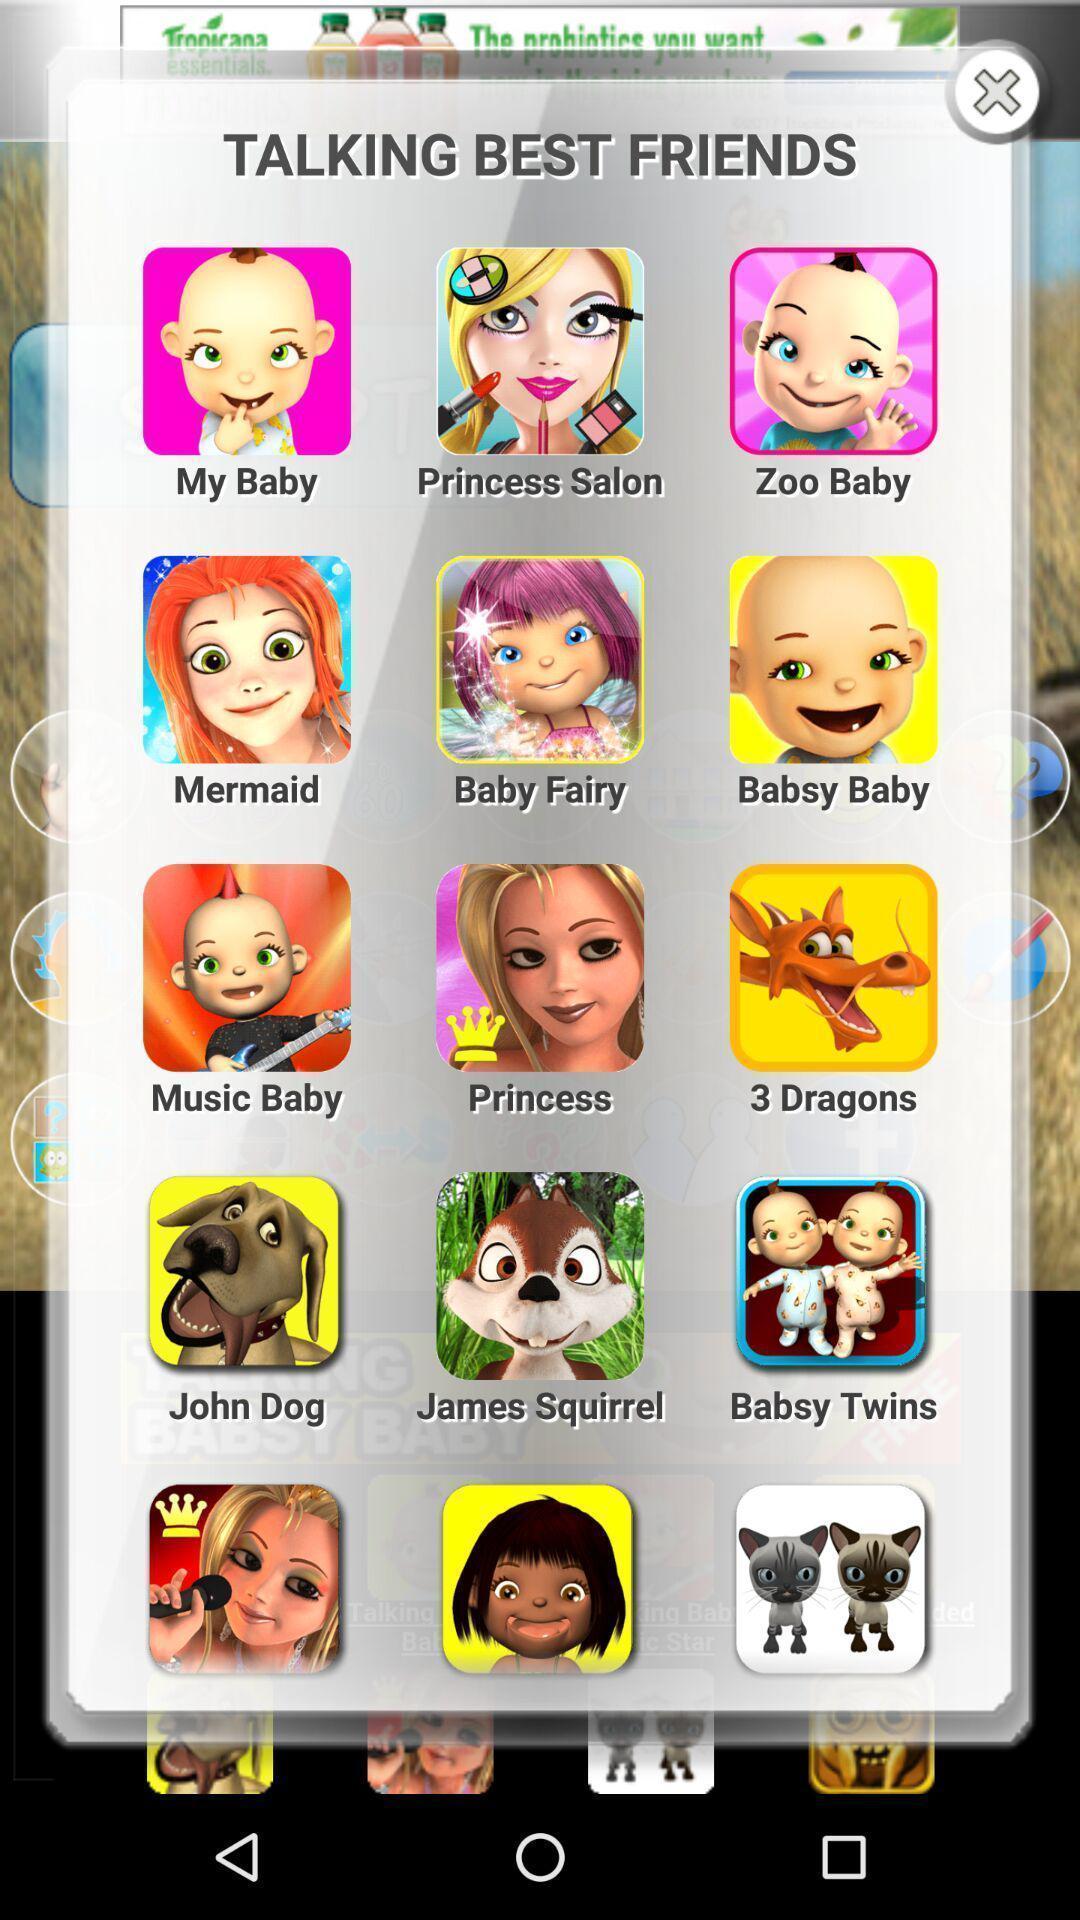Provide a textual representation of this image. Pop-up window is showing lot of sticker profiles. 